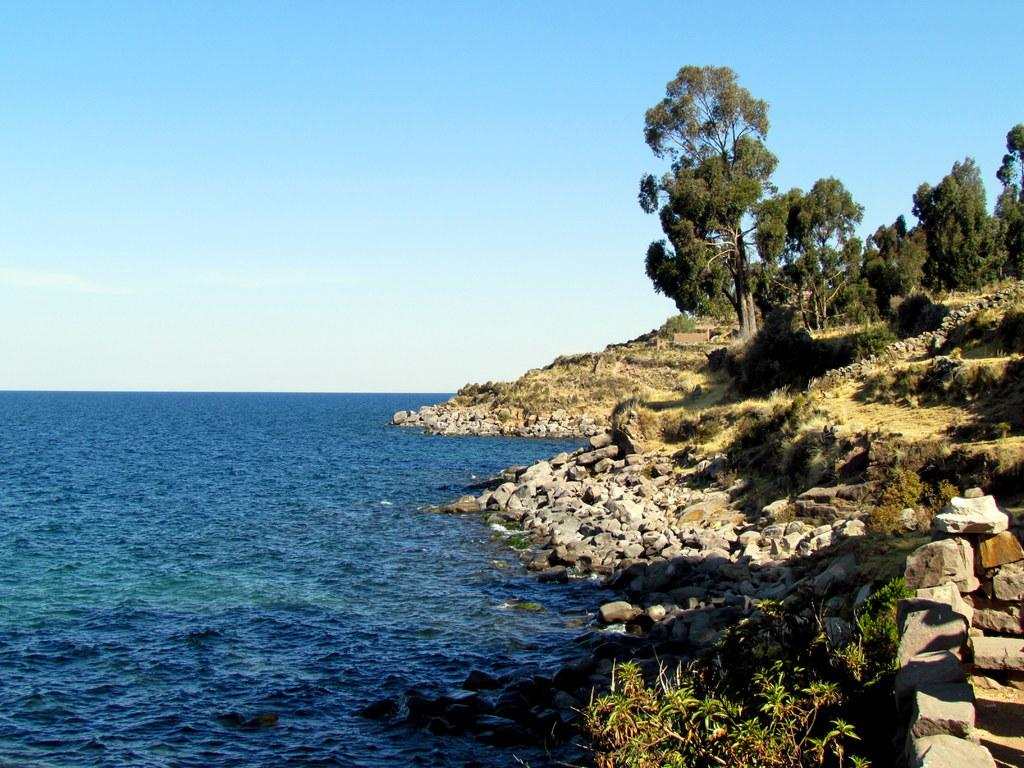What type of natural feature is located on the left side of the image? There is an ocean on the left side of the image. What type of natural feature is located on the right side of the image? There is a mountain on the right side of the image. What type of vegetation can be seen in the image? There are trees and plants in the image. What type of geological feature can be seen in the image? There are rocks in the image. What is the condition of the sky in the image? The sky is clear in the image. How many trucks are parked near the box in the image? There are no trucks or boxes present in the image. 